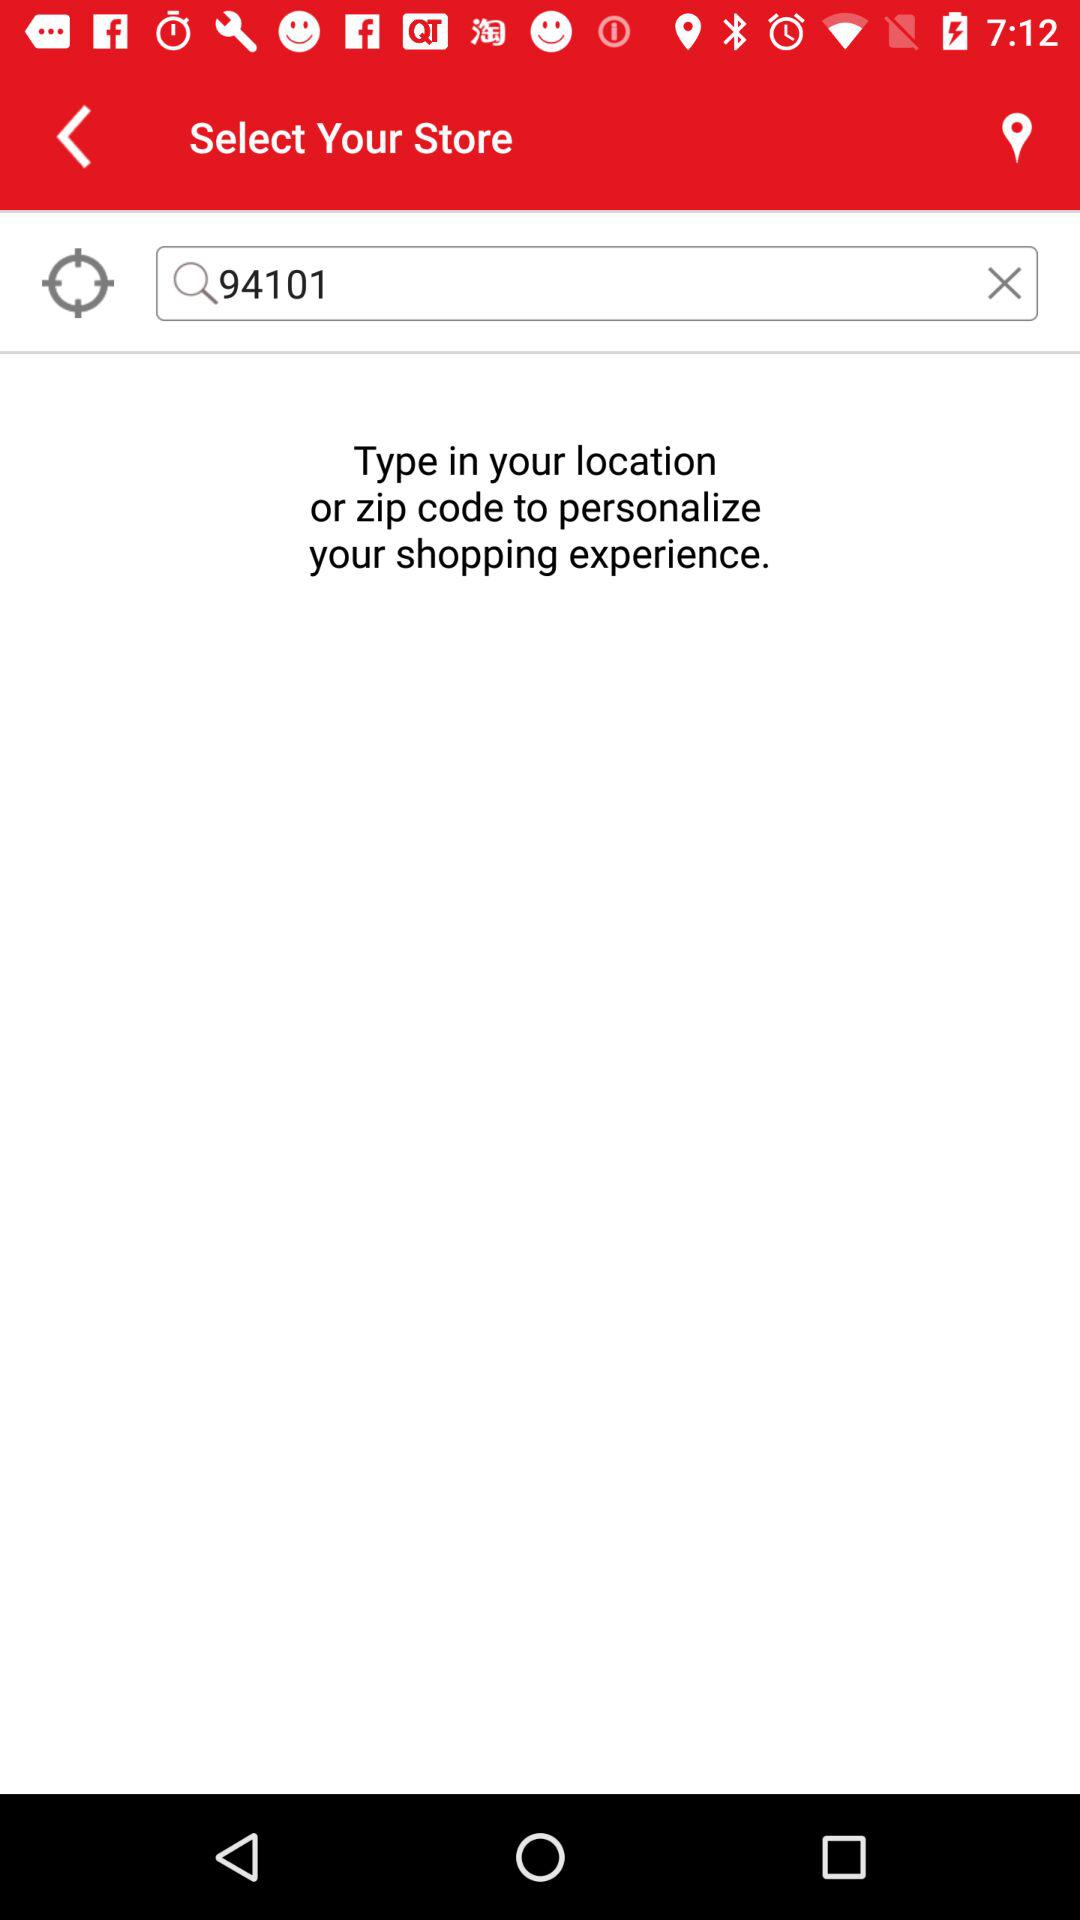How many text input fields are there on the screen?
Answer the question using a single word or phrase. 1 